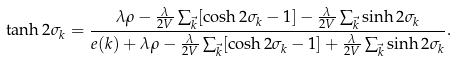Convert formula to latex. <formula><loc_0><loc_0><loc_500><loc_500>\tanh 2 \sigma _ { k } = \frac { \lambda \rho - \frac { \lambda } { 2 V } \sum _ { \vec { k } } [ \cosh 2 \sigma _ { k } - 1 ] - \frac { \lambda } { 2 V } \sum _ { \vec { k } } { \sinh 2 \sigma _ { k } } } { e ( k ) + \lambda \rho - \frac { \lambda } { 2 V } \sum _ { \vec { k } } [ \cosh 2 \sigma _ { k } - 1 ] + \frac { \lambda } { 2 V } \sum _ { \vec { k } } { \sinh 2 \sigma _ { k } } } .</formula> 